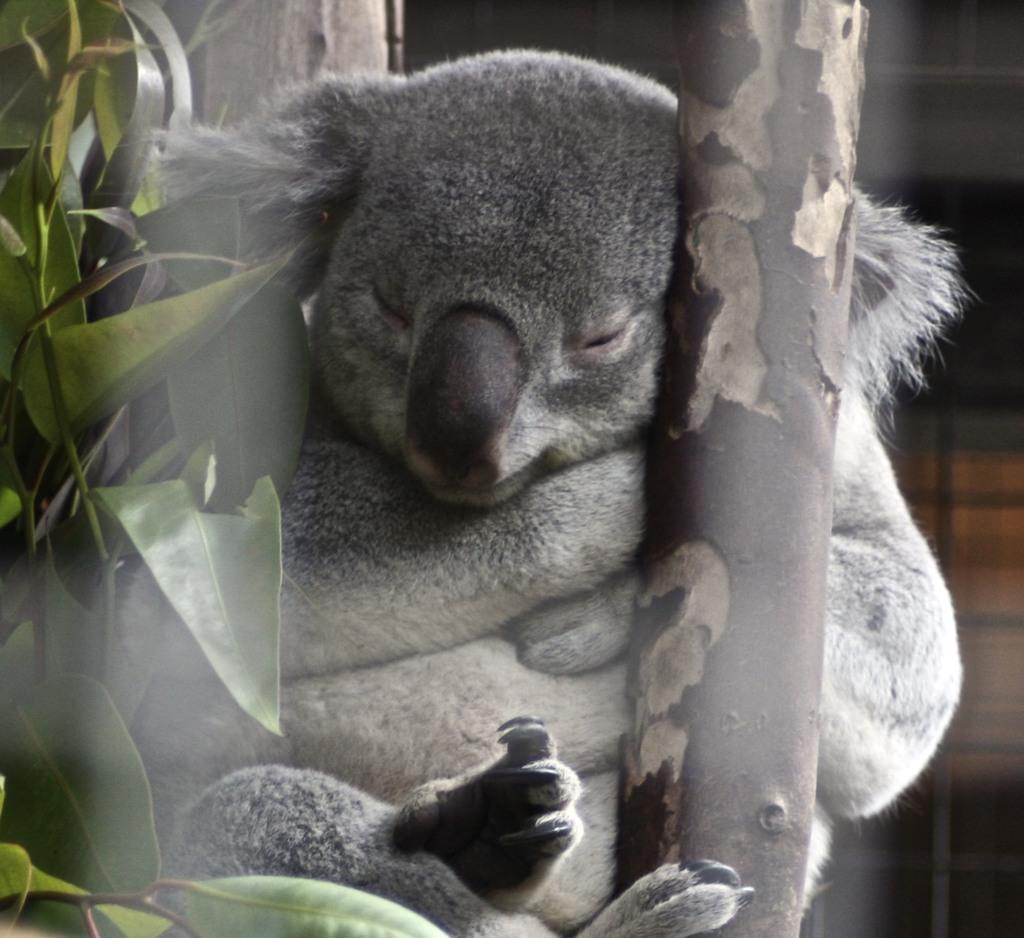Could you give a brief overview of what you see in this image? In this image I can see koalas. There are leaves, branches and the background is blurry. 